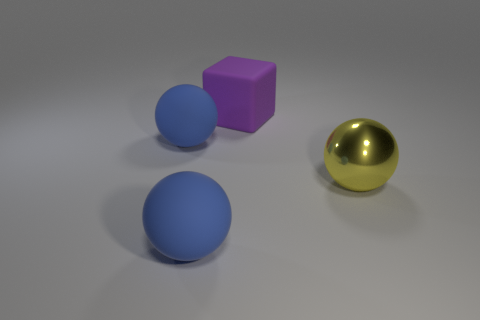Can you describe the lighting setup that might have been used to create the shadows in this image? The soft-edged shadows and evenly lit objects suggest the use of diffuse, ambient lighting in the scene, perhaps from a large overhead light source simulating soft daylight. There are no harsh shadows or strong highlights, indicating there aren't very focused or intense light sources. 